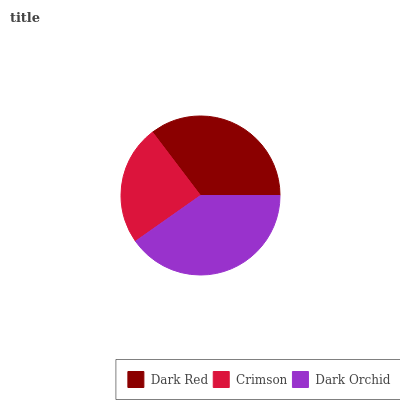Is Crimson the minimum?
Answer yes or no. Yes. Is Dark Orchid the maximum?
Answer yes or no. Yes. Is Dark Orchid the minimum?
Answer yes or no. No. Is Crimson the maximum?
Answer yes or no. No. Is Dark Orchid greater than Crimson?
Answer yes or no. Yes. Is Crimson less than Dark Orchid?
Answer yes or no. Yes. Is Crimson greater than Dark Orchid?
Answer yes or no. No. Is Dark Orchid less than Crimson?
Answer yes or no. No. Is Dark Red the high median?
Answer yes or no. Yes. Is Dark Red the low median?
Answer yes or no. Yes. Is Dark Orchid the high median?
Answer yes or no. No. Is Dark Orchid the low median?
Answer yes or no. No. 